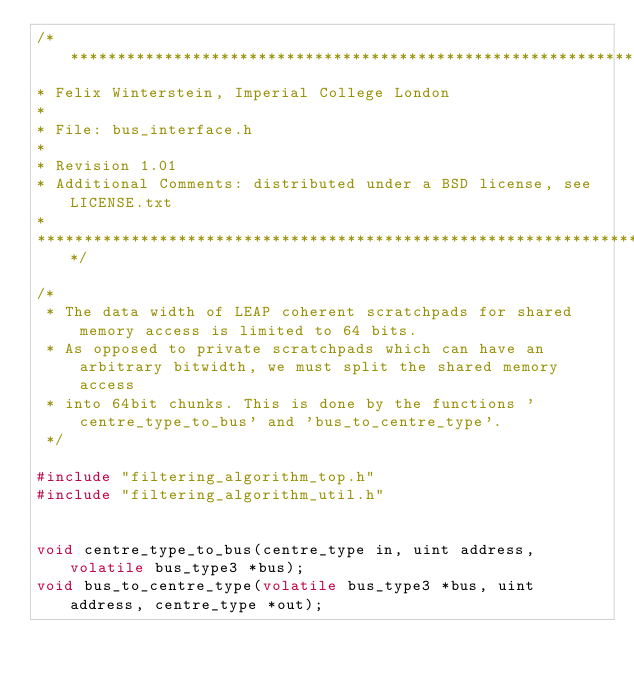Convert code to text. <code><loc_0><loc_0><loc_500><loc_500><_C_>/**********************************************************************
* Felix Winterstein, Imperial College London
*
* File: bus_interface.h
*
* Revision 1.01
* Additional Comments: distributed under a BSD license, see LICENSE.txt
*
**********************************************************************/

/*
 * The data width of LEAP coherent scratchpads for shared memory access is limited to 64 bits.
 * As opposed to private scratchpads which can have an arbitrary bitwidth, we must split the shared memory access
 * into 64bit chunks. This is done by the functions 'centre_type_to_bus' and 'bus_to_centre_type'.
 */

#include "filtering_algorithm_top.h"
#include "filtering_algorithm_util.h"


void centre_type_to_bus(centre_type in, uint address, volatile bus_type3 *bus);
void bus_to_centre_type(volatile bus_type3 *bus, uint address, centre_type *out);


</code> 